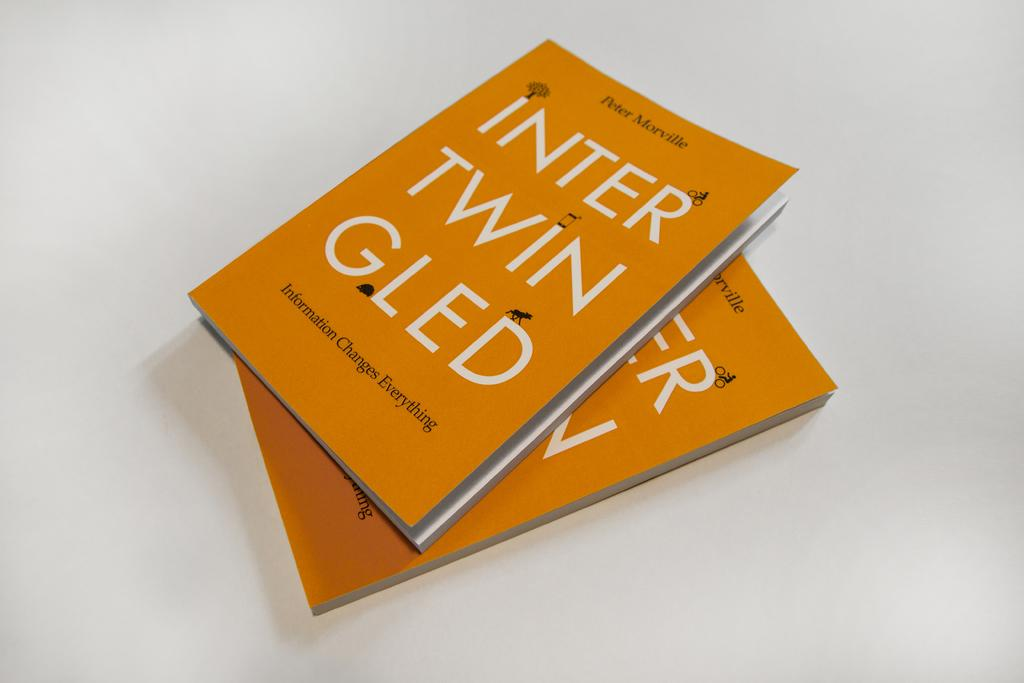<image>
Provide a brief description of the given image. Two copies of a book written by Peter Morville. 